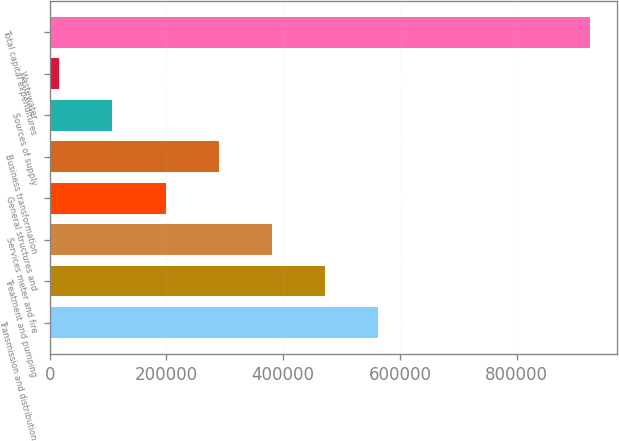<chart> <loc_0><loc_0><loc_500><loc_500><bar_chart><fcel>Transmission and distribution<fcel>Treatment and pumping<fcel>Services meter and fire<fcel>General structures and<fcel>Business transformation<fcel>Sources of supply<fcel>Wastewater<fcel>Total capital expenditures<nl><fcel>561664<fcel>470865<fcel>380066<fcel>198469<fcel>289268<fcel>107671<fcel>16872<fcel>924858<nl></chart> 